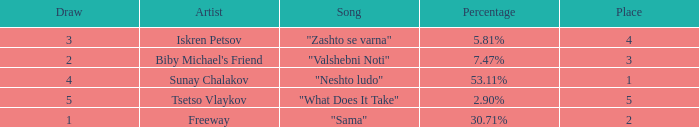What is the least draw when the place is higher than 4? 5.0. 